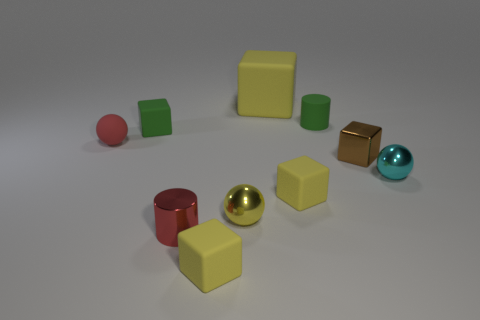Subtract all tiny red metallic objects. Subtract all large blue metallic balls. How many objects are left? 9 Add 4 tiny matte spheres. How many tiny matte spheres are left? 5 Add 2 small red metallic cylinders. How many small red metallic cylinders exist? 3 Subtract all green cubes. How many cubes are left? 4 Subtract all yellow blocks. How many blocks are left? 2 Subtract 0 gray spheres. How many objects are left? 10 Subtract all cylinders. How many objects are left? 8 Subtract 1 cylinders. How many cylinders are left? 1 Subtract all gray spheres. Subtract all green cylinders. How many spheres are left? 3 Subtract all brown cubes. How many yellow balls are left? 1 